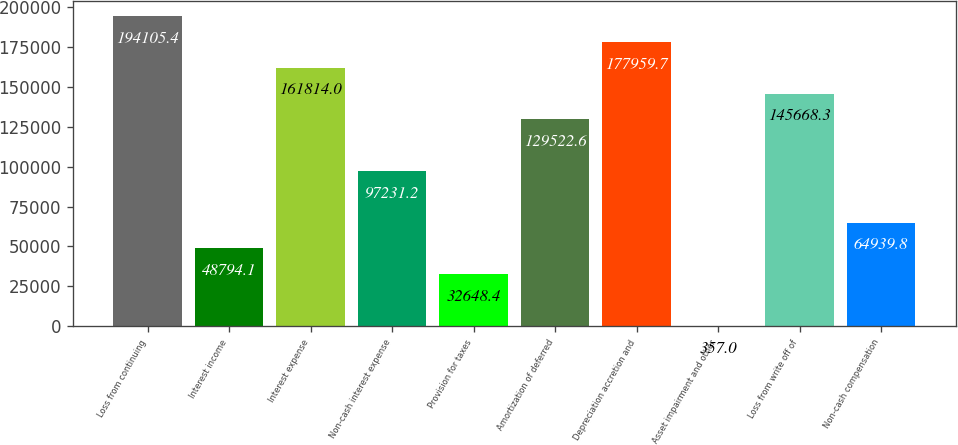Convert chart. <chart><loc_0><loc_0><loc_500><loc_500><bar_chart><fcel>Loss from continuing<fcel>Interest income<fcel>Interest expense<fcel>Non-cash interest expense<fcel>Provision for taxes<fcel>Amortization of deferred<fcel>Depreciation accretion and<fcel>Asset impairment and other<fcel>Loss from write off of<fcel>Non-cash compensation<nl><fcel>194105<fcel>48794.1<fcel>161814<fcel>97231.2<fcel>32648.4<fcel>129523<fcel>177960<fcel>357<fcel>145668<fcel>64939.8<nl></chart> 